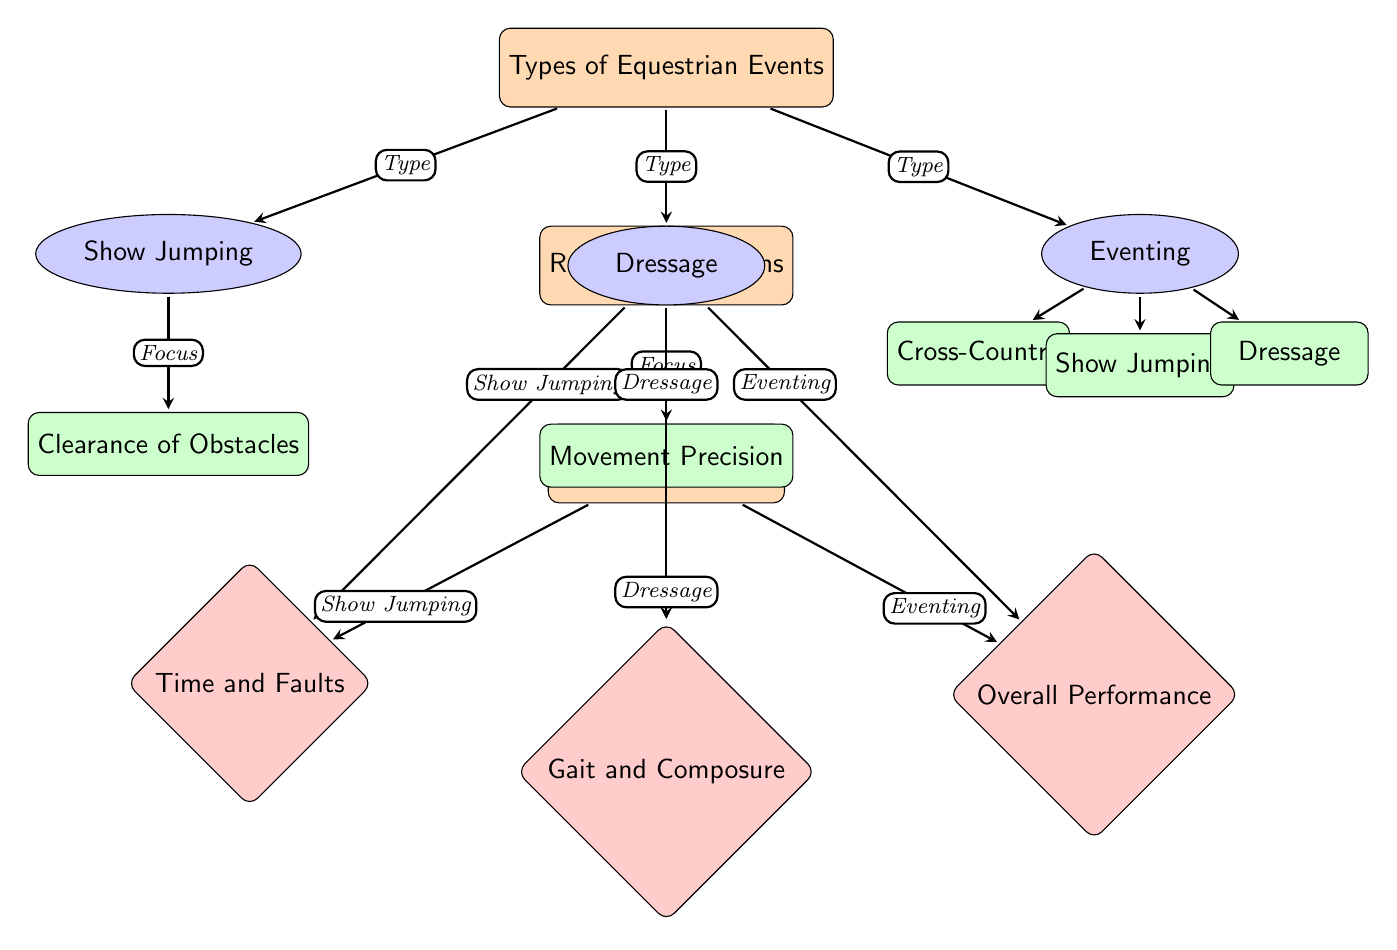What are the three main types of equestrian events? The diagram lists three types: Show Jumping, Dressage, and Eventing.
Answer: Show Jumping, Dressage, Eventing Which sub-event is associated with Show Jumping? According to the diagram, the sub-event directly under Show Jumping is Clearance of Obstacles.
Answer: Clearance of Obstacles What judging criteria is linked to Dressage? The diagram indicates that the judging criteria related to Dressage is Gait and Composure.
Answer: Gait and Composure How many sub-events are listed under Eventing? By reviewing the diagram, we see there are three sub-events listed under Eventing: Cross-Country, Show Jumping, and Dressage.
Answer: 3 What is the focus of the sub-event related to Dressage? The diagram specifies that the focus for the Dressage sub-event is Movement Precision.
Answer: Movement Precision Which equestrian event type does the judging criteria "Overall Performance" apply to? The diagram connects Overall Performance to the Eventing type, indicating that this judging criterion is specific to Eventing.
Answer: Eventing How many main nodes are shown in the diagram? The visible main nodes include Types of Equestrian Events, Rules & Regulations, and Judging Criteria, totaling to three main nodes.
Answer: 3 Which type of equestrian event is associated with "Time and Faults"? The diagram shows that "Time and Faults" are linked explicitly to Show Jumping as the judging criteria.
Answer: Show Jumping What are the specific areas of focus for the eventing sub-events? The focus areas for eventing, according to the diagram, include Cross-Country, Show Jumping, and Dressage.
Answer: Cross-Country, Show Jumping, Dressage 